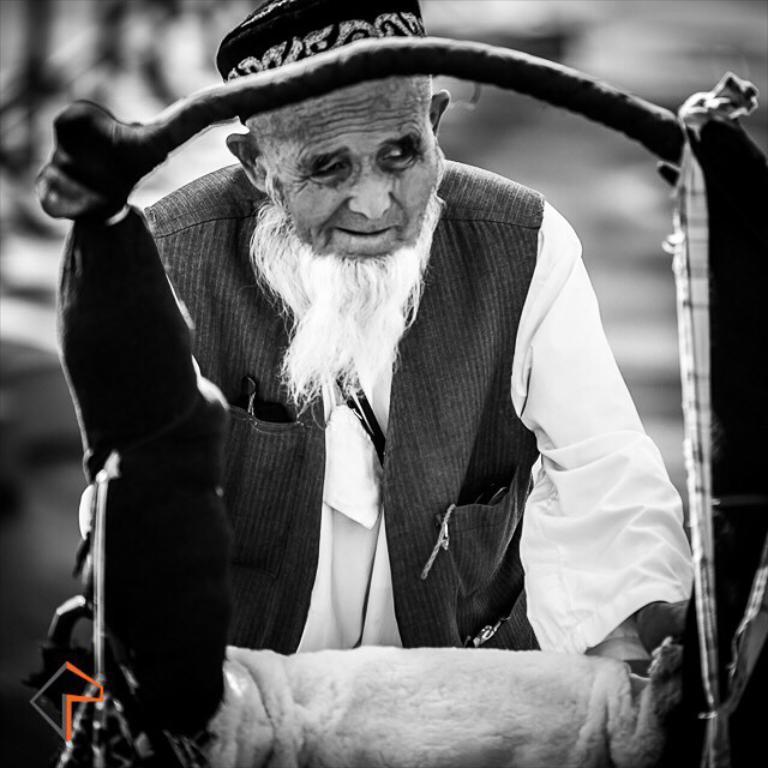How would you summarize this image in a sentence or two? This is a black and white image and here we can see a person wearing a cap and there is a stand and a cloth and a logo. 